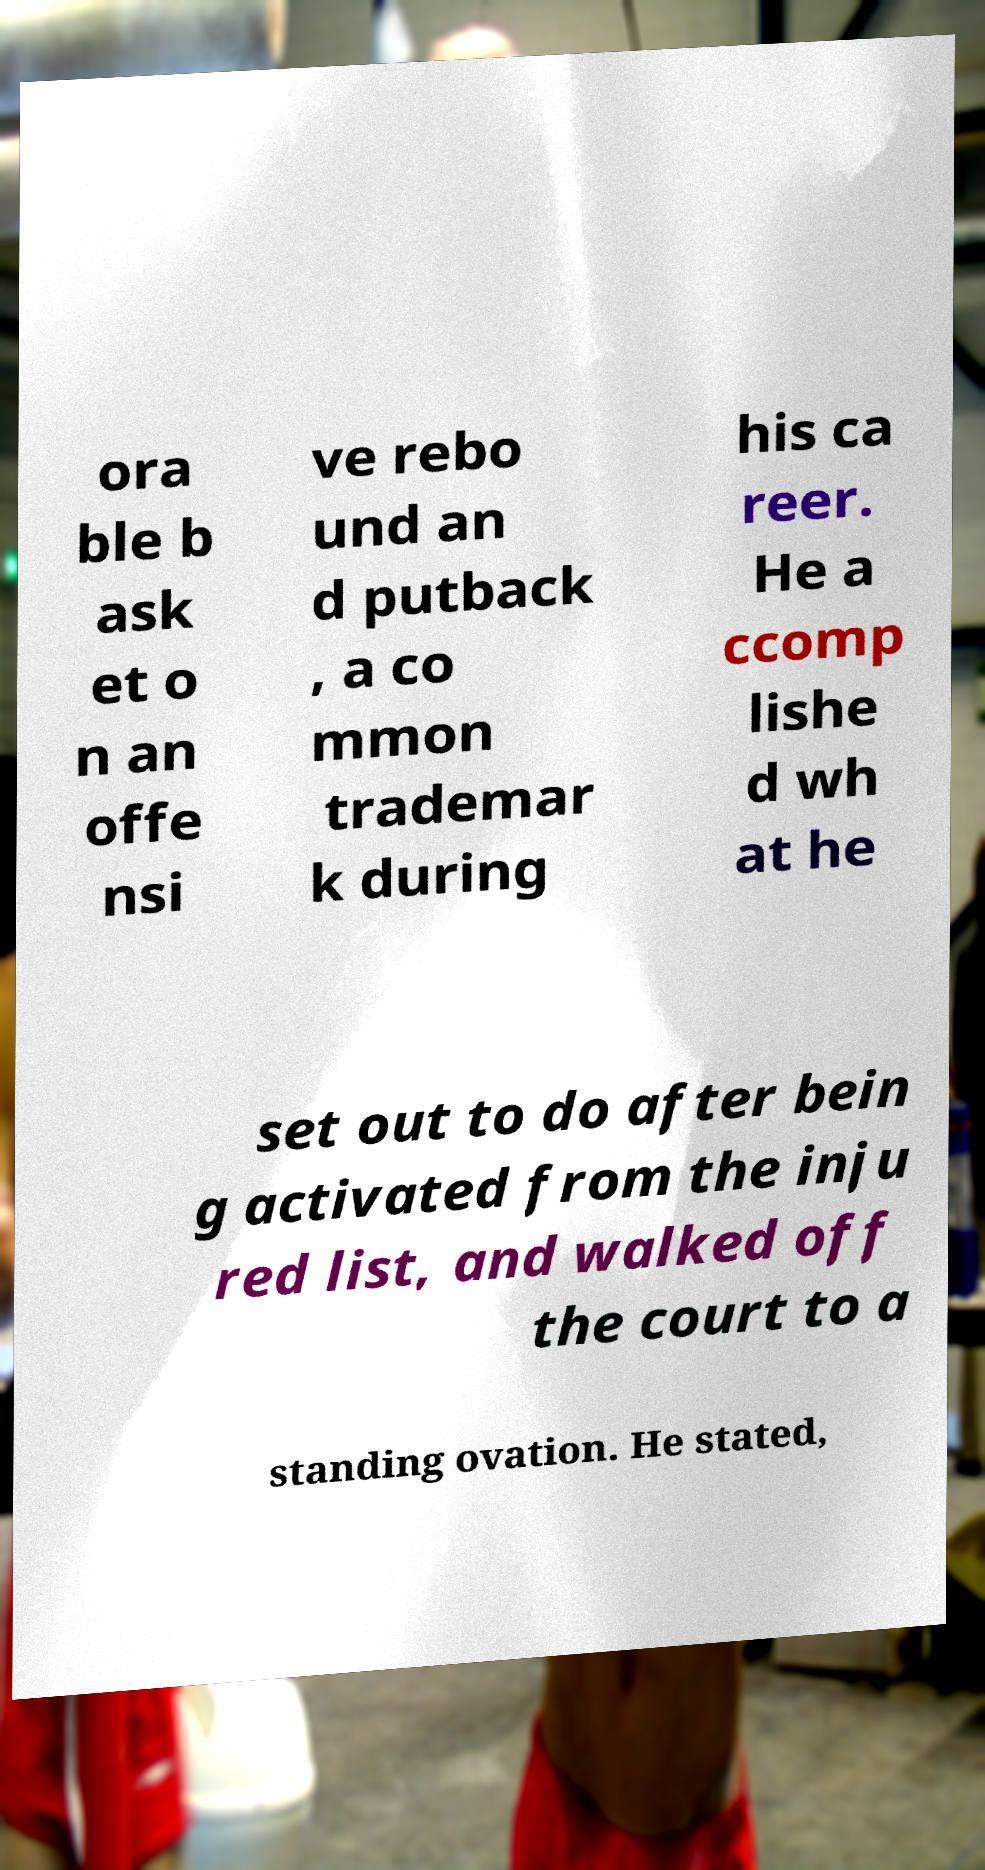Can you accurately transcribe the text from the provided image for me? ora ble b ask et o n an offe nsi ve rebo und an d putback , a co mmon trademar k during his ca reer. He a ccomp lishe d wh at he set out to do after bein g activated from the inju red list, and walked off the court to a standing ovation. He stated, 